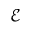Convert formula to latex. <formula><loc_0><loc_0><loc_500><loc_500>\mathcal { E }</formula> 